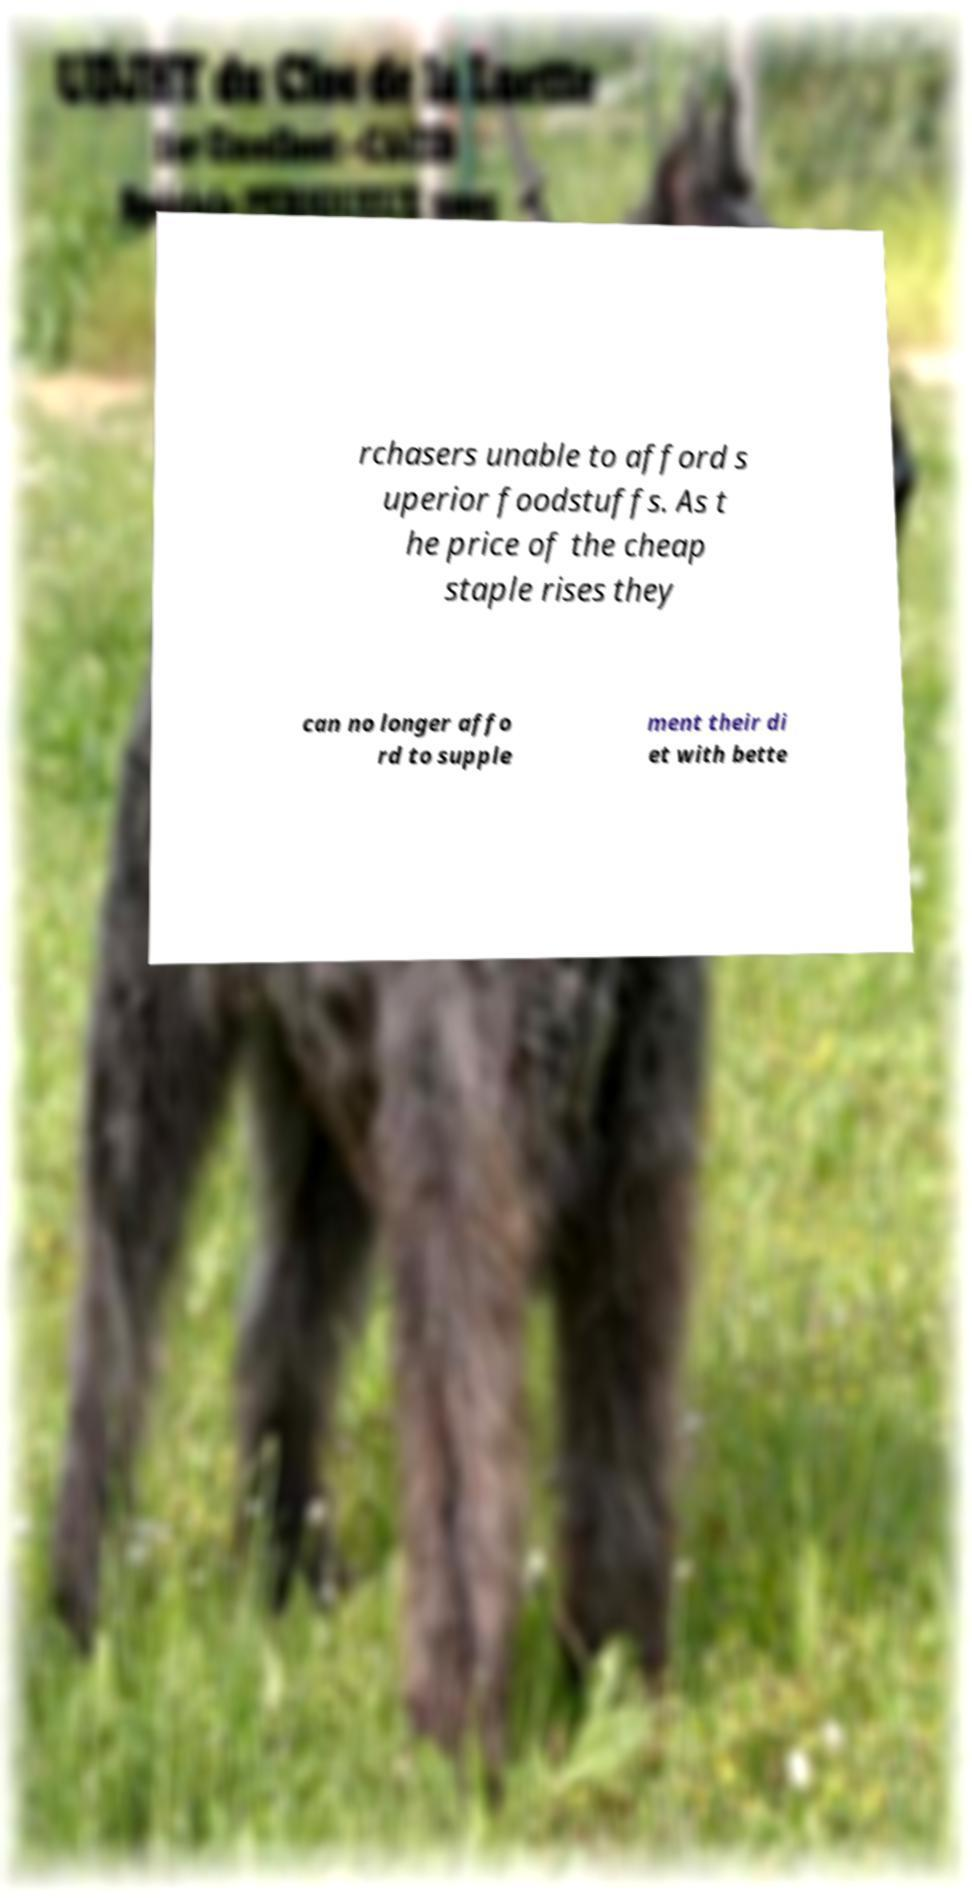Please read and relay the text visible in this image. What does it say? rchasers unable to afford s uperior foodstuffs. As t he price of the cheap staple rises they can no longer affo rd to supple ment their di et with bette 